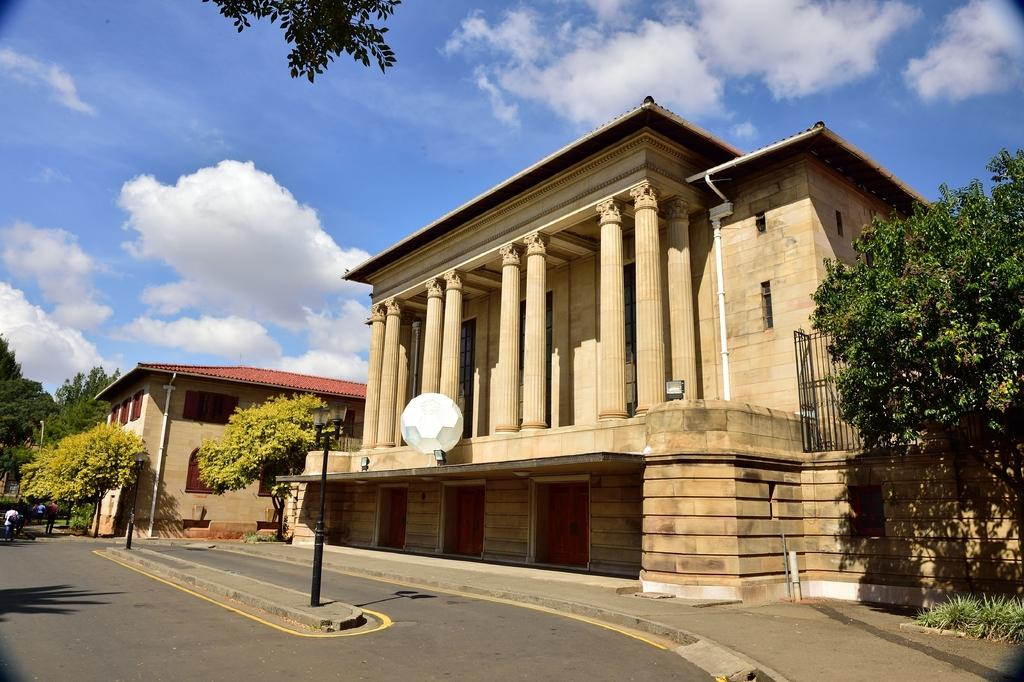What is the main feature of the image? There is a road in the image. What else can be seen along the road? There are poles in the image. Are there any living beings present in the image? Yes, there are people in the image. What can be seen in the background of the image? There are trees, buildings, and the sky visible in the background of the image. What is the texture of the zinc in the image? There is no zinc present in the image, so it is not possible to determine its texture. 